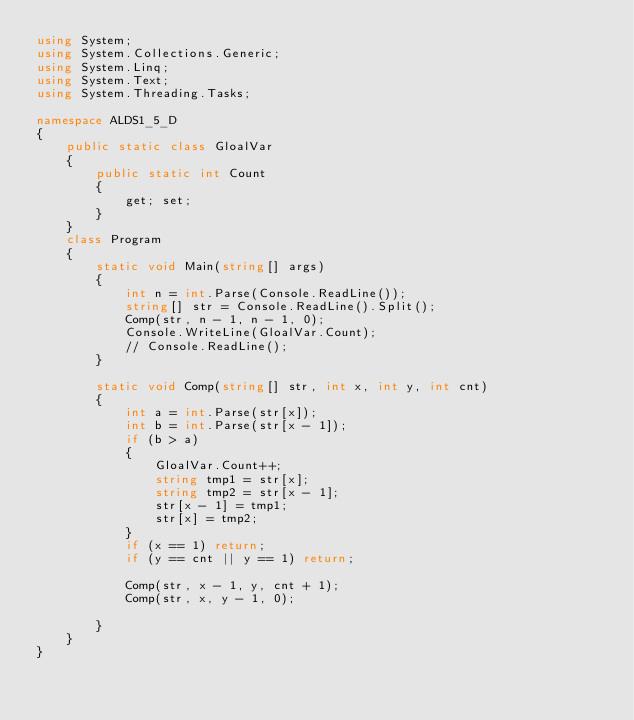<code> <loc_0><loc_0><loc_500><loc_500><_C#_>using System;
using System.Collections.Generic;
using System.Linq;
using System.Text;
using System.Threading.Tasks;

namespace ALDS1_5_D
{
    public static class GloalVar
    {
        public static int Count
        {
            get; set;
        }
    }
    class Program
    {
        static void Main(string[] args)
        {
            int n = int.Parse(Console.ReadLine());
            string[] str = Console.ReadLine().Split();
            Comp(str, n - 1, n - 1, 0);
            Console.WriteLine(GloalVar.Count);
            // Console.ReadLine();
        }

        static void Comp(string[] str, int x, int y, int cnt)
        {
            int a = int.Parse(str[x]);
            int b = int.Parse(str[x - 1]);
            if (b > a)
            {
                GloalVar.Count++;
                string tmp1 = str[x];
                string tmp2 = str[x - 1];
                str[x - 1] = tmp1;
                str[x] = tmp2;
            }
            if (x == 1) return;
            if (y == cnt || y == 1) return;

            Comp(str, x - 1, y, cnt + 1);
            Comp(str, x, y - 1, 0);
            
        }
    }
}

</code> 